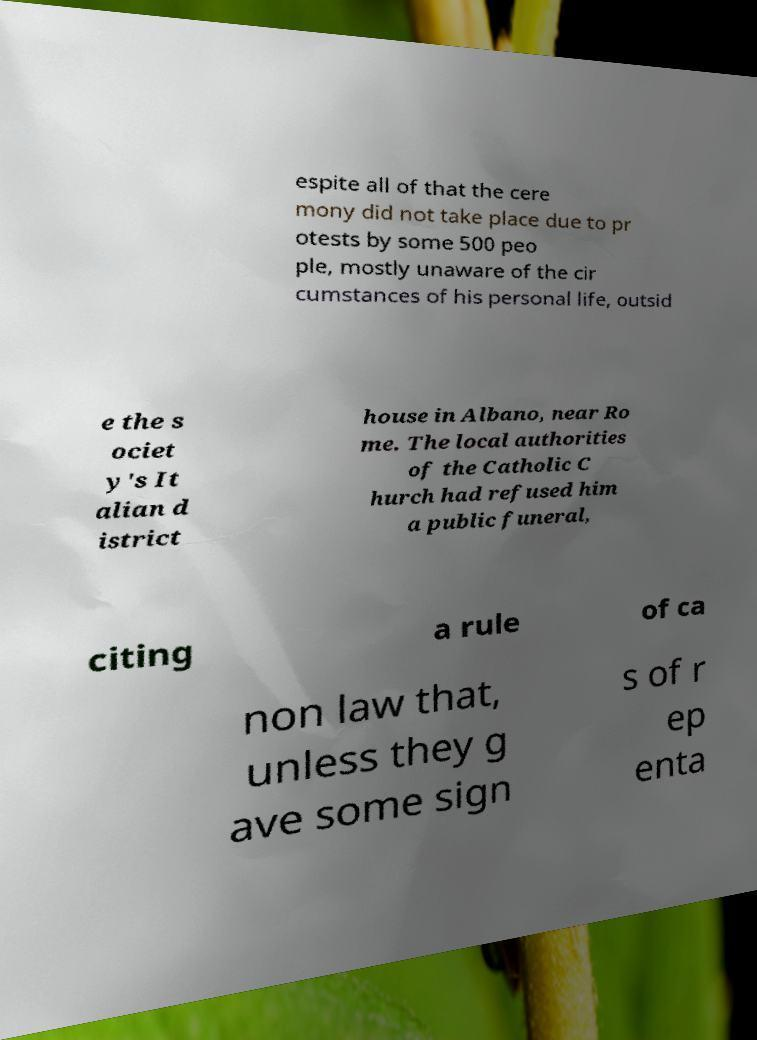Can you accurately transcribe the text from the provided image for me? espite all of that the cere mony did not take place due to pr otests by some 500 peo ple, mostly unaware of the cir cumstances of his personal life, outsid e the s ociet y's It alian d istrict house in Albano, near Ro me. The local authorities of the Catholic C hurch had refused him a public funeral, citing a rule of ca non law that, unless they g ave some sign s of r ep enta 